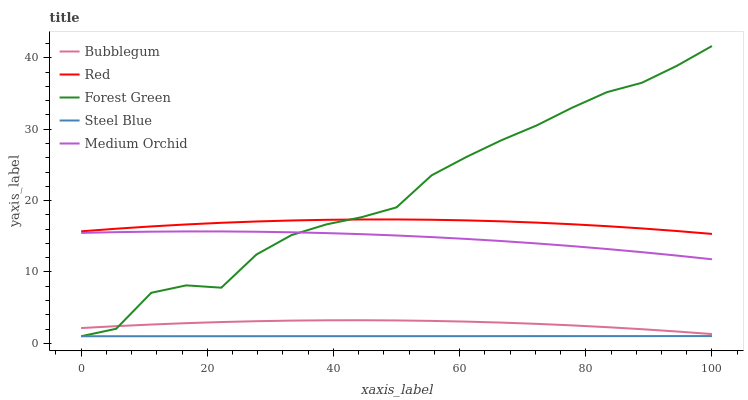Does Steel Blue have the minimum area under the curve?
Answer yes or no. Yes. Does Forest Green have the maximum area under the curve?
Answer yes or no. Yes. Does Medium Orchid have the minimum area under the curve?
Answer yes or no. No. Does Medium Orchid have the maximum area under the curve?
Answer yes or no. No. Is Steel Blue the smoothest?
Answer yes or no. Yes. Is Forest Green the roughest?
Answer yes or no. Yes. Is Medium Orchid the smoothest?
Answer yes or no. No. Is Medium Orchid the roughest?
Answer yes or no. No. Does Medium Orchid have the lowest value?
Answer yes or no. No. Does Forest Green have the highest value?
Answer yes or no. Yes. Does Medium Orchid have the highest value?
Answer yes or no. No. Is Bubblegum less than Red?
Answer yes or no. Yes. Is Red greater than Steel Blue?
Answer yes or no. Yes. Does Forest Green intersect Red?
Answer yes or no. Yes. Is Forest Green less than Red?
Answer yes or no. No. Is Forest Green greater than Red?
Answer yes or no. No. Does Bubblegum intersect Red?
Answer yes or no. No. 